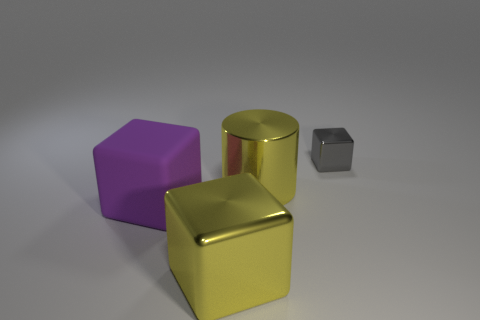Do the gray thing and the big yellow thing that is to the left of the large yellow metal cylinder have the same shape?
Provide a succinct answer. Yes. What number of other things are there of the same shape as the tiny thing?
Offer a very short reply. 2. What number of objects are purple matte cubes or yellow cubes?
Your response must be concise. 2. Do the shiny cylinder and the tiny metallic thing have the same color?
Provide a succinct answer. No. Are there any other things that are the same size as the matte cube?
Keep it short and to the point. Yes. The big yellow thing that is behind the big metallic cube on the right side of the matte cube is what shape?
Offer a terse response. Cylinder. Is the number of tiny gray cylinders less than the number of yellow cubes?
Your response must be concise. Yes. What is the size of the thing that is behind the large matte block and left of the tiny cube?
Make the answer very short. Large. Do the purple matte thing and the gray cube have the same size?
Your response must be concise. No. There is a shiny block that is in front of the yellow cylinder; is it the same color as the big matte thing?
Your response must be concise. No. 